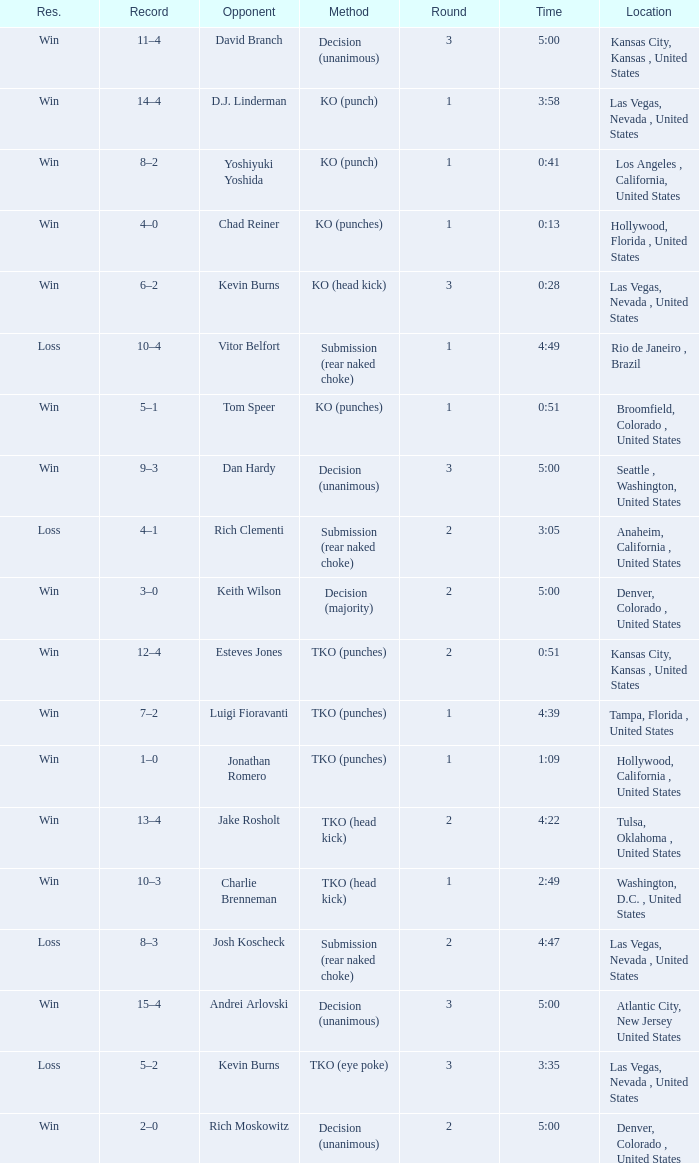What is the highest round number with a time of 4:39? 1.0. 